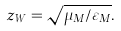Convert formula to latex. <formula><loc_0><loc_0><loc_500><loc_500>z _ { W } = \sqrt { \mu _ { M } / \varepsilon _ { M } } .</formula> 